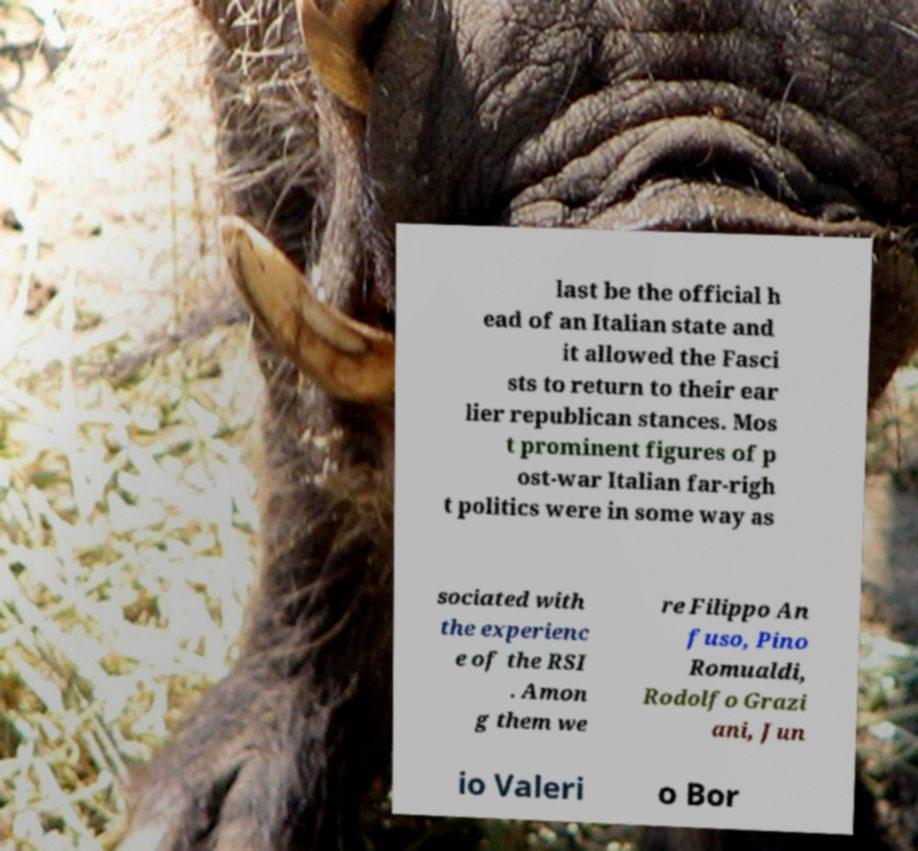Please read and relay the text visible in this image. What does it say? last be the official h ead of an Italian state and it allowed the Fasci sts to return to their ear lier republican stances. Mos t prominent figures of p ost-war Italian far-righ t politics were in some way as sociated with the experienc e of the RSI . Amon g them we re Filippo An fuso, Pino Romualdi, Rodolfo Grazi ani, Jun io Valeri o Bor 